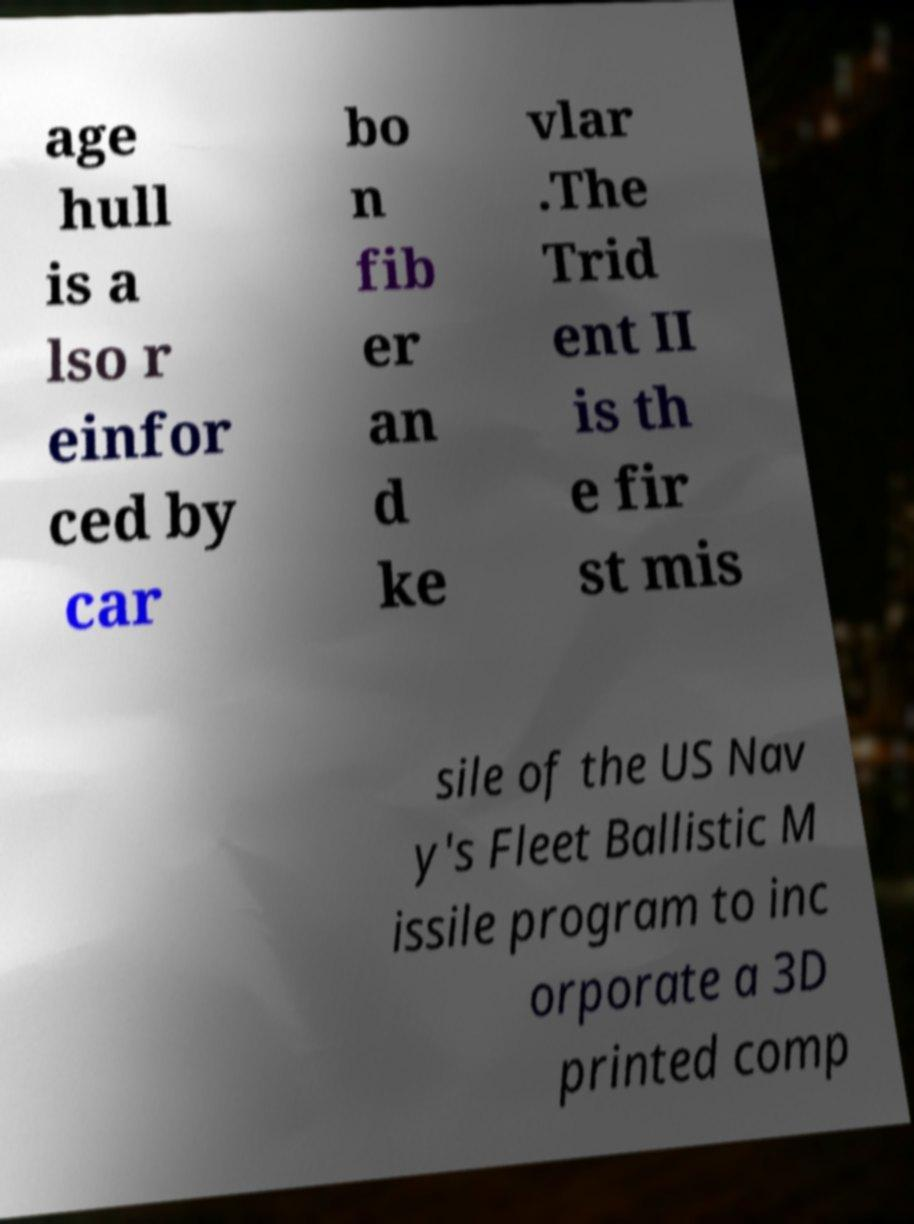There's text embedded in this image that I need extracted. Can you transcribe it verbatim? age hull is a lso r einfor ced by car bo n fib er an d ke vlar .The Trid ent II is th e fir st mis sile of the US Nav y's Fleet Ballistic M issile program to inc orporate a 3D printed comp 